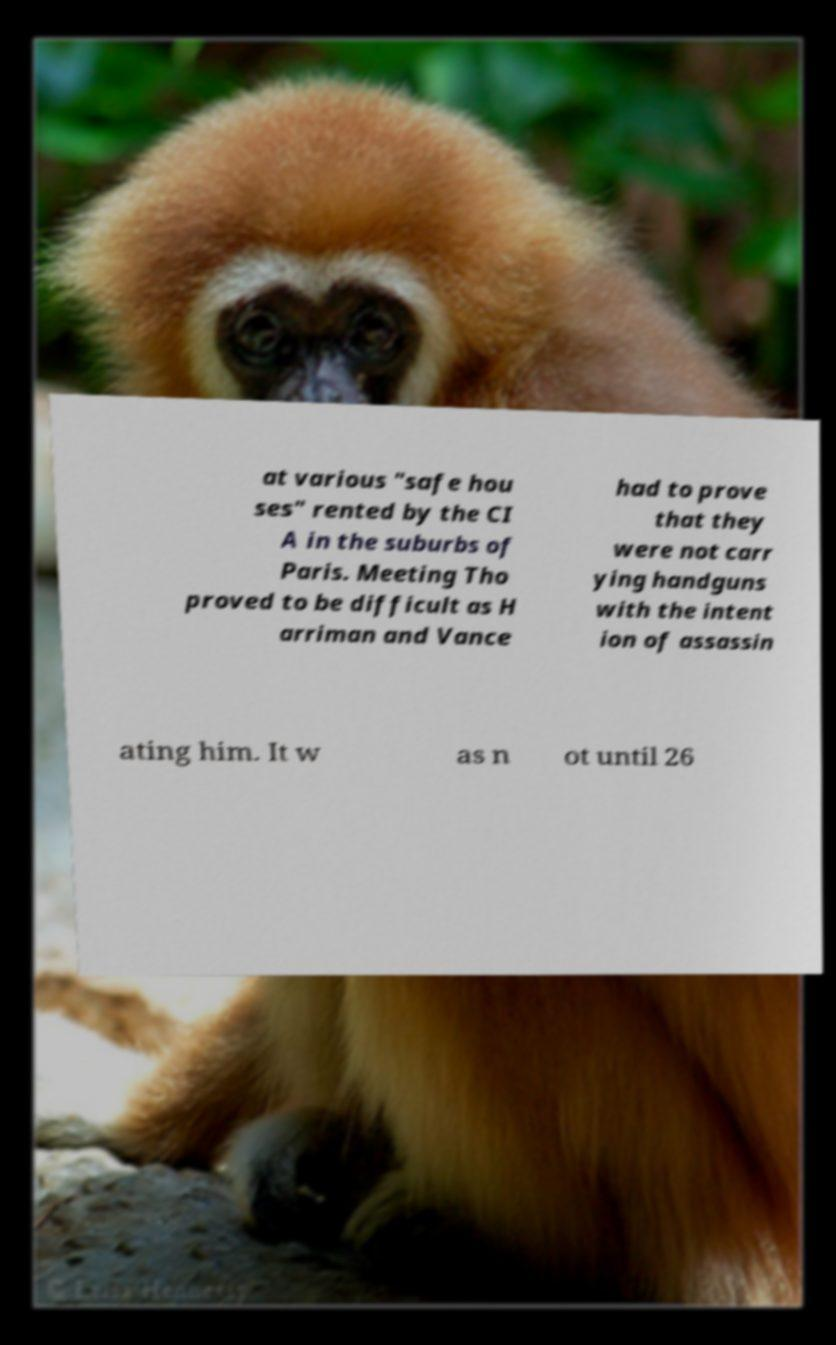Please identify and transcribe the text found in this image. at various "safe hou ses" rented by the CI A in the suburbs of Paris. Meeting Tho proved to be difficult as H arriman and Vance had to prove that they were not carr ying handguns with the intent ion of assassin ating him. It w as n ot until 26 